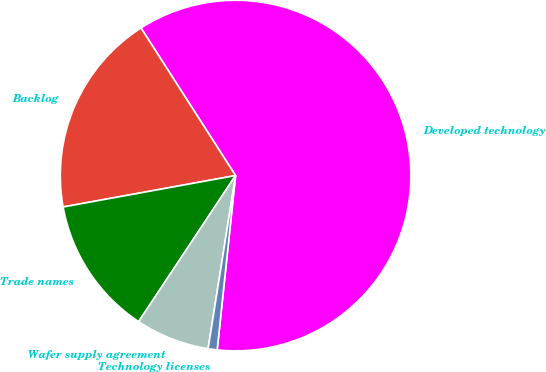Convert chart. <chart><loc_0><loc_0><loc_500><loc_500><pie_chart><fcel>Developed technology<fcel>Backlog<fcel>Trade names<fcel>Wafer supply agreement<fcel>Technology licenses<nl><fcel>60.74%<fcel>18.8%<fcel>12.81%<fcel>6.82%<fcel>0.83%<nl></chart> 